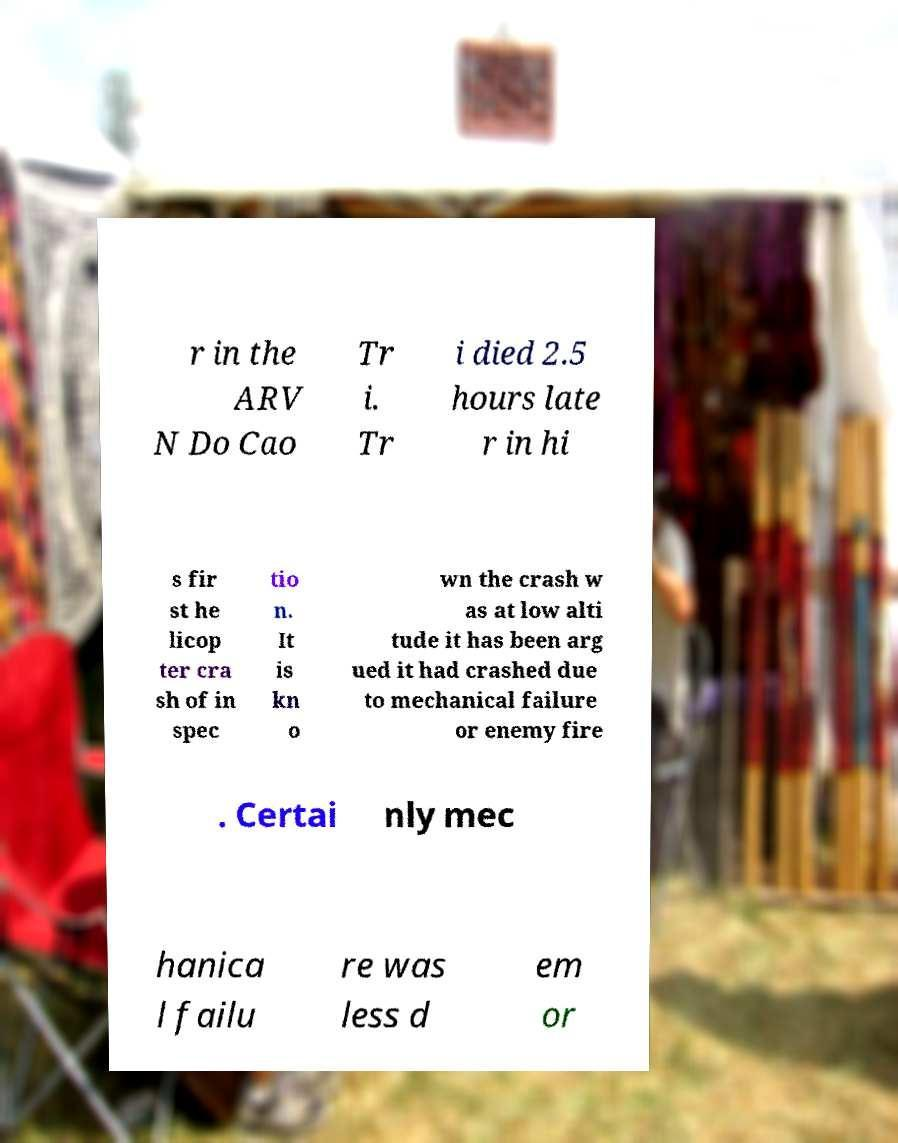What messages or text are displayed in this image? I need them in a readable, typed format. r in the ARV N Do Cao Tr i. Tr i died 2.5 hours late r in hi s fir st he licop ter cra sh of in spec tio n. It is kn o wn the crash w as at low alti tude it has been arg ued it had crashed due to mechanical failure or enemy fire . Certai nly mec hanica l failu re was less d em or 